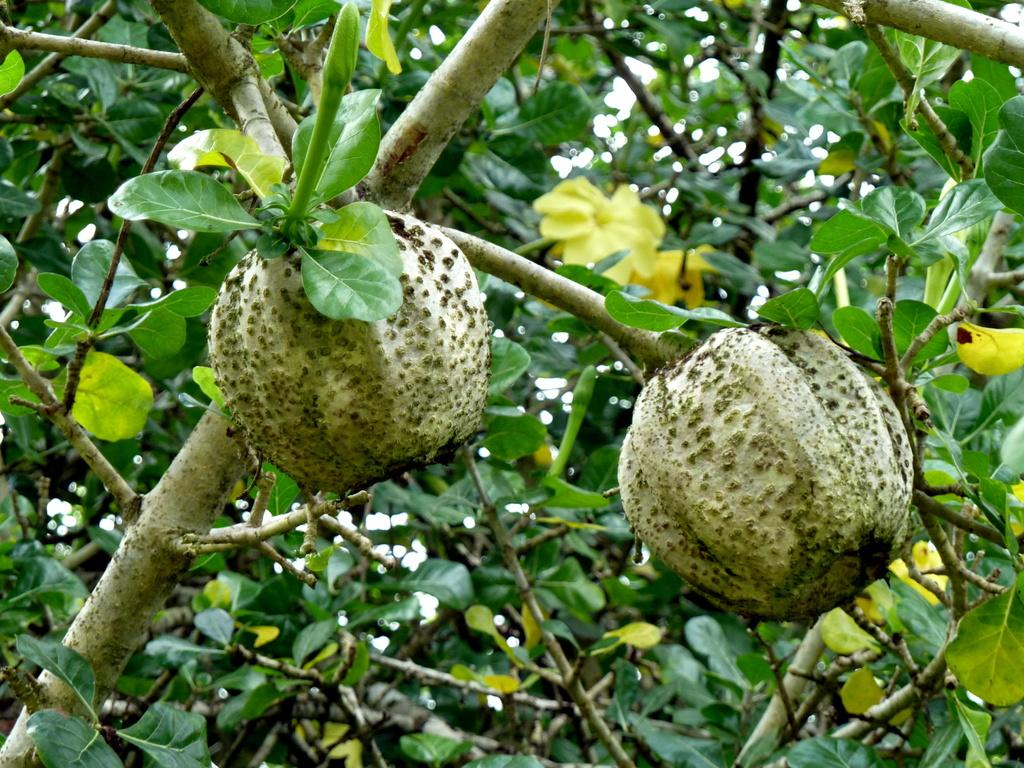What type of plant can be seen in the image? There is a tree in the image. What features can be observed on the tree? The tree has fruits, flowers, buds, and leaves. What is the color of the flowers on the tree? The flowers on the tree are yellow in color. Are there any children involved in a crime scene near the tree in the image? There is no mention of children or a crime scene in the image; it only features a tree with various features. 